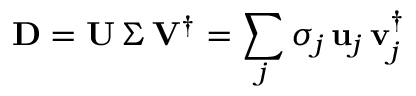Convert formula to latex. <formula><loc_0><loc_0><loc_500><loc_500>D = U \, \Sigma \, V ^ { \dagger } = \sum _ { j } \sigma _ { j } \, u _ { j } \, v _ { j } ^ { \dagger }</formula> 